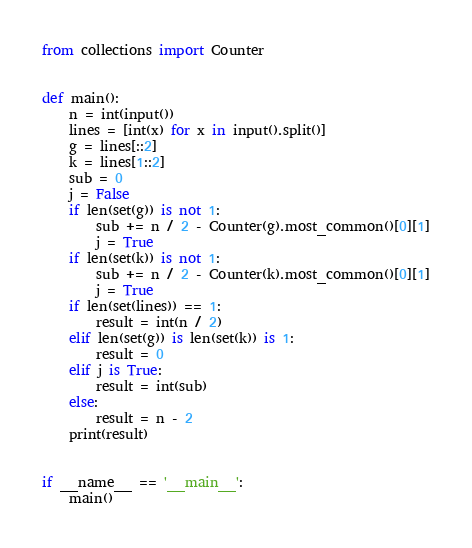Convert code to text. <code><loc_0><loc_0><loc_500><loc_500><_Python_>from collections import Counter


def main():
    n = int(input())
    lines = [int(x) for x in input().split()]
    g = lines[::2]
    k = lines[1::2]
    sub = 0
    j = False
    if len(set(g)) is not 1:
        sub += n / 2 - Counter(g).most_common()[0][1]
        j = True
    if len(set(k)) is not 1:
        sub += n / 2 - Counter(k).most_common()[0][1]
        j = True
    if len(set(lines)) == 1:
        result = int(n / 2)
    elif len(set(g)) is len(set(k)) is 1:
        result = 0
    elif j is True:
        result = int(sub)
    else:
        result = n - 2
    print(result)


if __name__ == '__main__':
    main()
</code> 